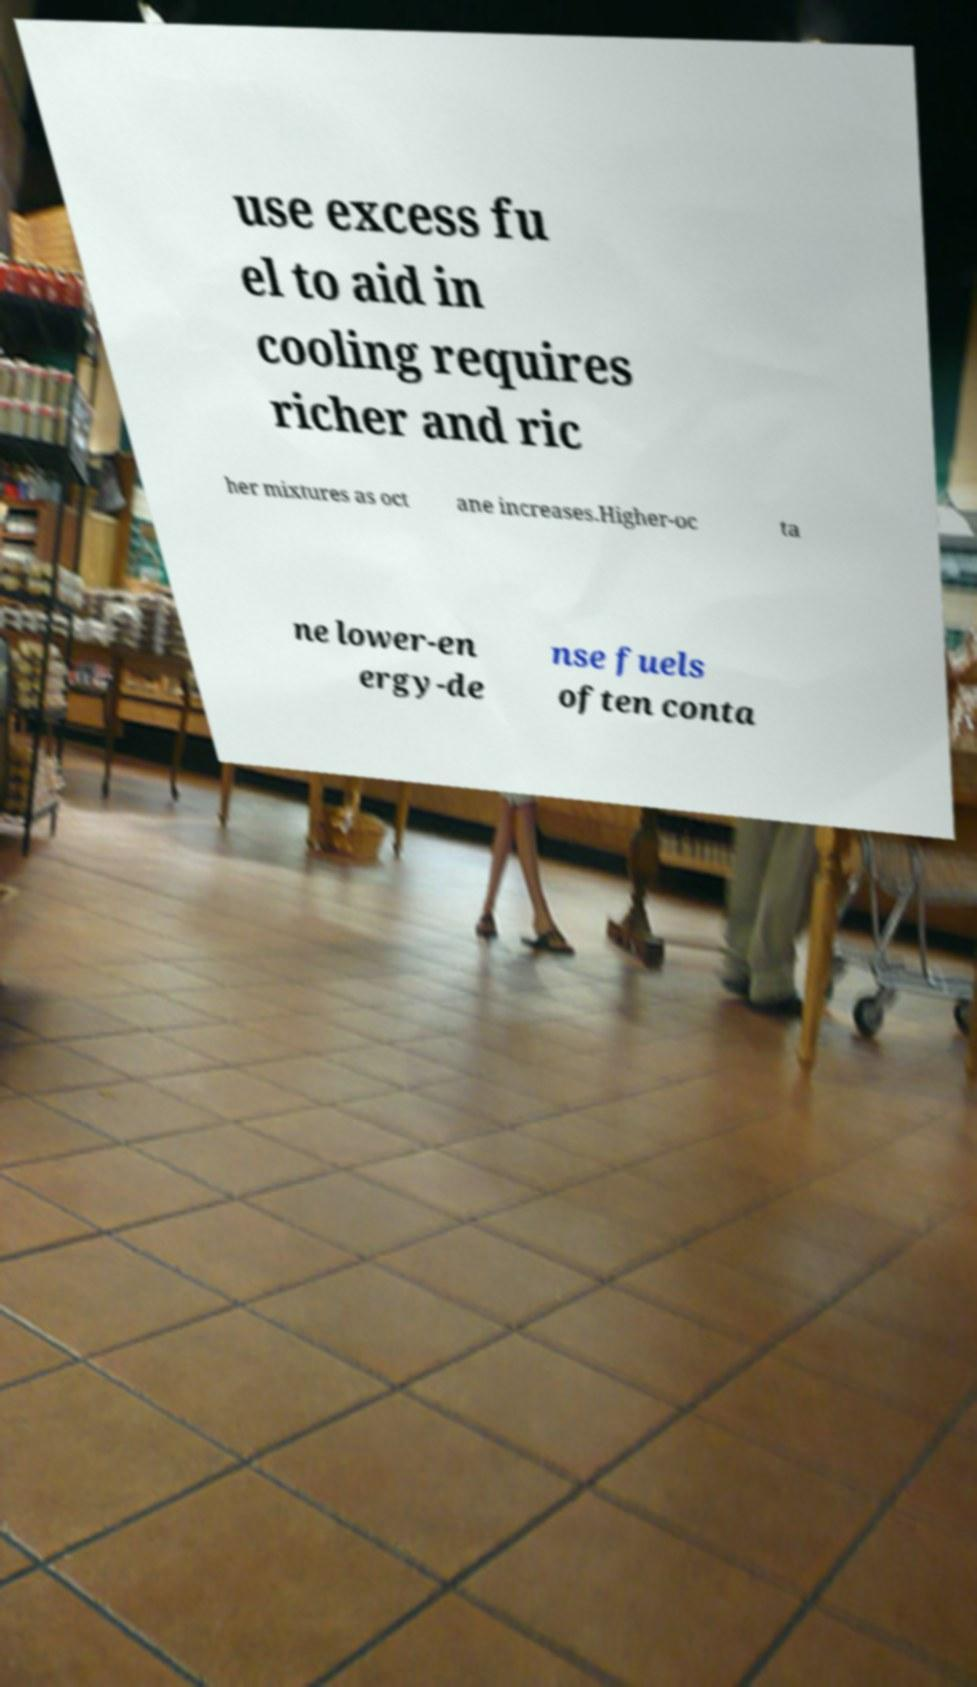What messages or text are displayed in this image? I need them in a readable, typed format. use excess fu el to aid in cooling requires richer and ric her mixtures as oct ane increases.Higher-oc ta ne lower-en ergy-de nse fuels often conta 